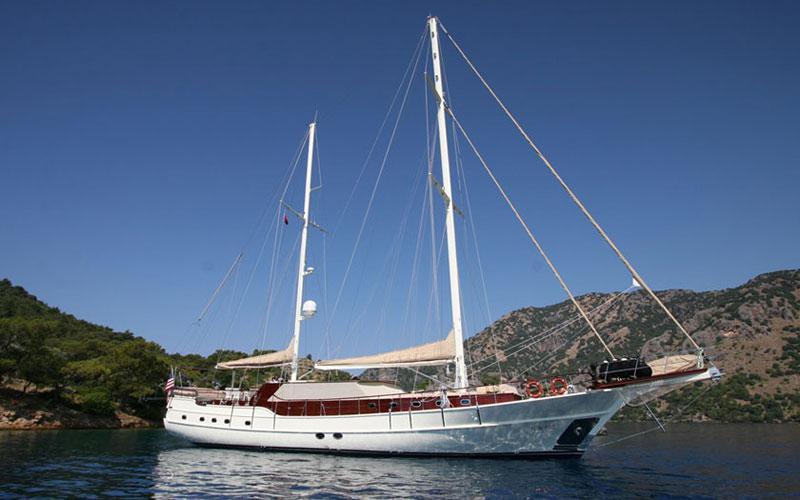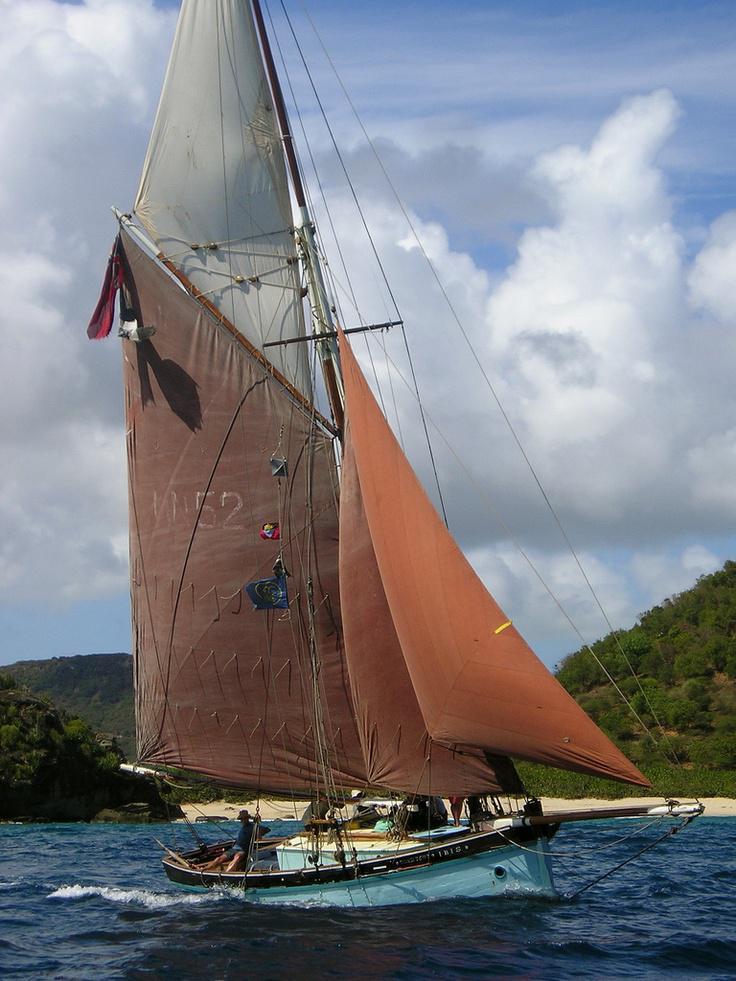The first image is the image on the left, the second image is the image on the right. Analyze the images presented: Is the assertion "There are no visible clouds in one of the images within the pair." valid? Answer yes or no. Yes. The first image is the image on the left, the second image is the image on the right. Examine the images to the left and right. Is the description "At least one of the ship has at least one sail that is not up." accurate? Answer yes or no. Yes. 